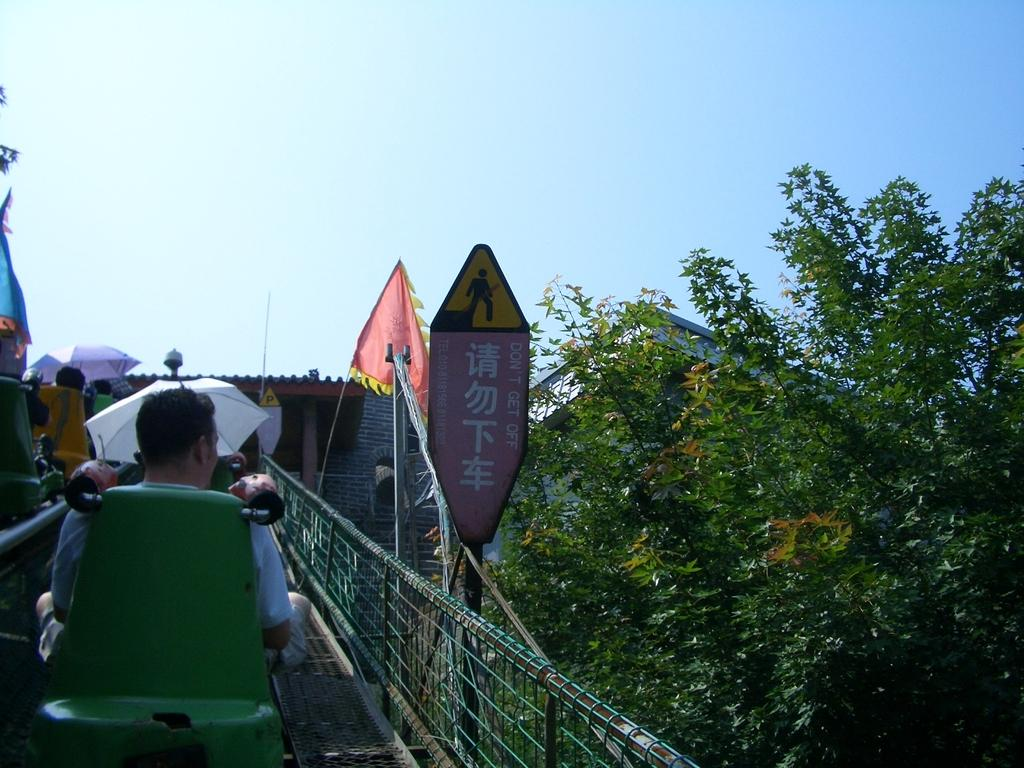Who or what can be seen in the image? There are people in the image. What structures are present in the image? There are sheds in the image. What type of vegetation is visible in the image? There are trees in the image. What feature allows for movement through the area in the image? There is a path in the image. How many babies are being cared for by the experts in the image? There are no experts or babies present in the image. What type of water feature can be seen flowing through the image? There is no water feature, such as a stream, present in the image. 